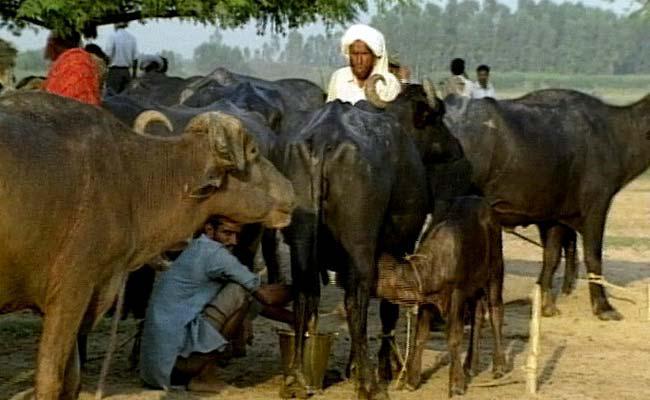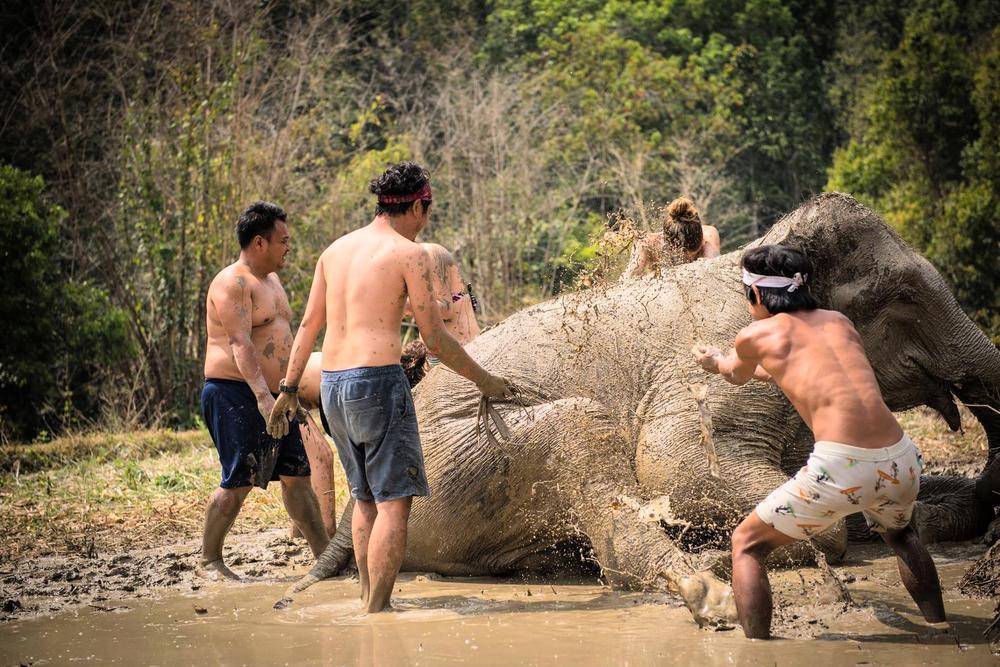The first image is the image on the left, the second image is the image on the right. Analyze the images presented: Is the assertion "Two hunters pose with a weapon behind a downed water buffalo in the left image." valid? Answer yes or no. No. The first image is the image on the left, the second image is the image on the right. Given the left and right images, does the statement "In one of the images, two men can be seen posing next to a deceased water buffalo." hold true? Answer yes or no. No. 